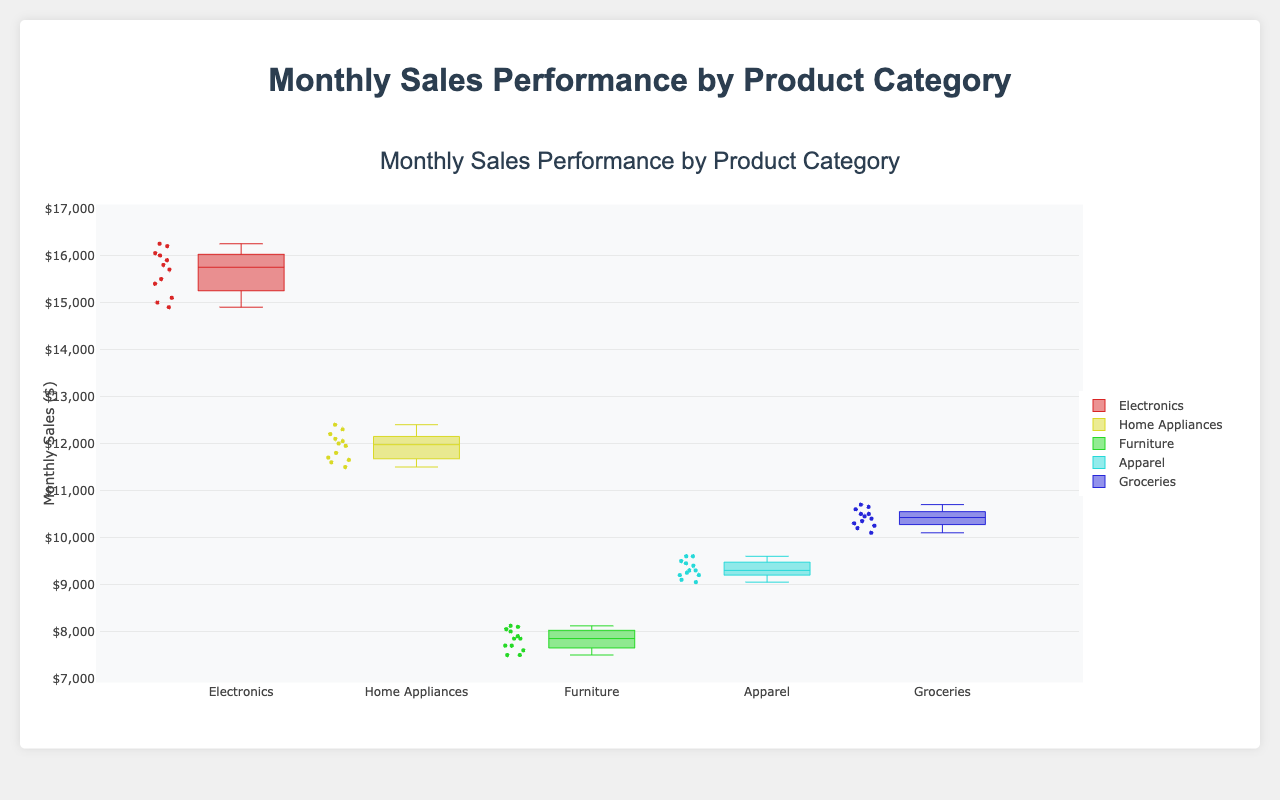What's the title of the figure? The title is displayed at the top of the figure in large font.
Answer: Monthly Sales Performance by Product Category What is the highest sales value for Electronics? By looking at the upper whisker of the Electronics box plot, the highest value is indicated.
Answer: 16250 Which product category has the lowest median monthly sales? The median is the line inside the box. By comparing all categories, Furniture has the lowest median.
Answer: Furniture What's the range of sales for Home Appliances? The range is the difference between the highest and lowest values (upper whisker minus lower whisker).
Answer: 12400 - 11500 = 900 Which product category shows the highest variability in monthly sales? Variability can be assessed by the length of the box and the whiskers. The longer the box and whiskers, the higher the variability.
Answer: Electronics How does the median sales of Groceries compare to Home Appliances? The median is indicated by the line inside the box. Compare the medians of Groceries and Home Appliances directly.
Answer: Groceries' median is slightly higher than Home Appliances' What is the interquartile range (IQR) for Apparel? The IQR is the difference between the upper quartile (top of the box) and lower quartile (bottom of the box) values for Apparel.
Answer: 9450 - 9200 = 250 How many data points are plotted for Furniture? Counting the individual data points shown within and around the box plot for Furniture.
Answer: 12 What is the third quartile (Q3) value for Electronics? Q3 is the value at the top of the box for Electronics.
Answer: 16050 Are there any outliers in the Groceries sales data? Outliers would appear as individual points outside the whiskers. There are no isolated points outside the whiskers for Groceries.
Answer: No 